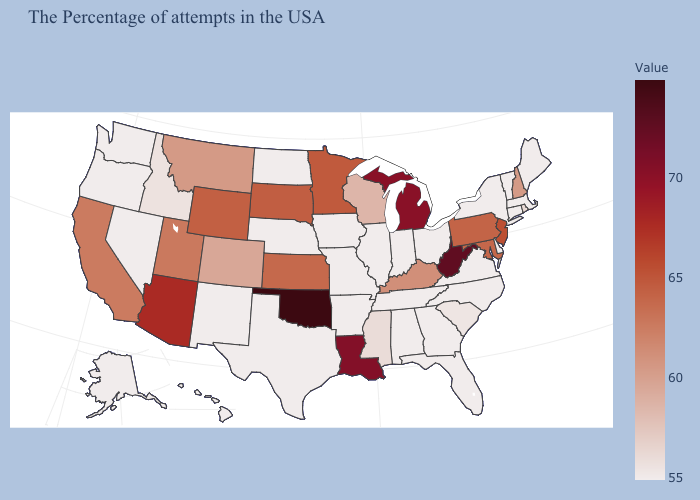Is the legend a continuous bar?
Concise answer only. Yes. Is the legend a continuous bar?
Give a very brief answer. Yes. Is the legend a continuous bar?
Concise answer only. Yes. 